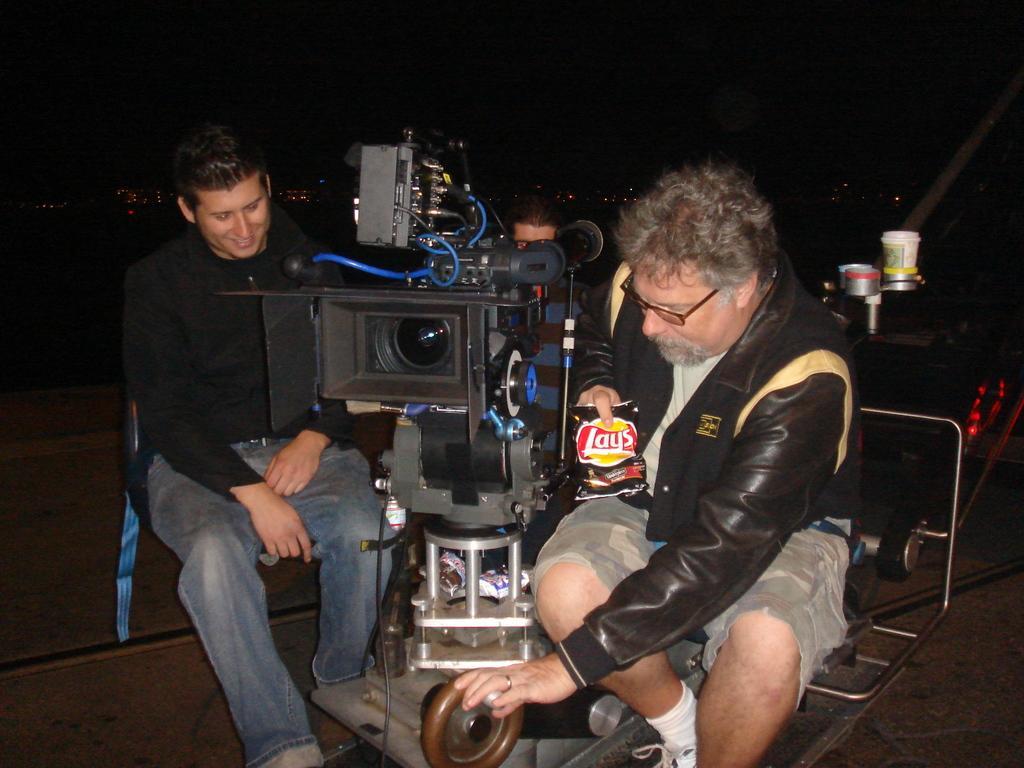How would you summarize this image in a sentence or two? In this image there are few persons sit on their chairs in between them there is a camera. The background is dark. 